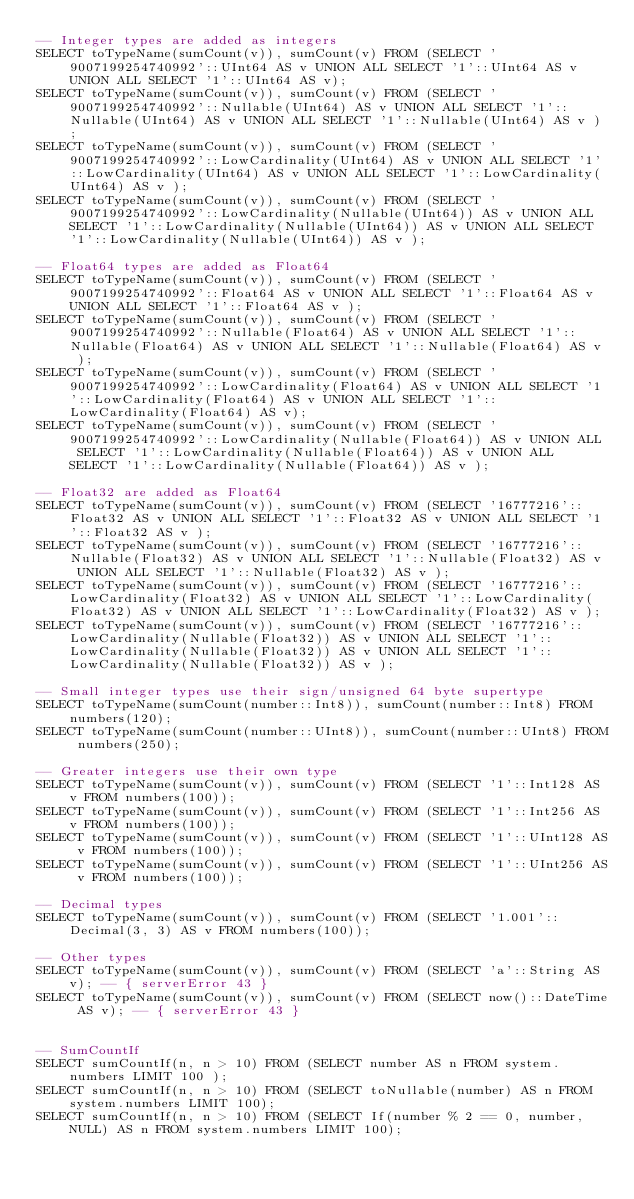Convert code to text. <code><loc_0><loc_0><loc_500><loc_500><_SQL_>-- Integer types are added as integers
SELECT toTypeName(sumCount(v)), sumCount(v) FROM (SELECT '9007199254740992'::UInt64 AS v UNION ALL SELECT '1'::UInt64 AS v UNION ALL SELECT '1'::UInt64 AS v);
SELECT toTypeName(sumCount(v)), sumCount(v) FROM (SELECT '9007199254740992'::Nullable(UInt64) AS v UNION ALL SELECT '1'::Nullable(UInt64) AS v UNION ALL SELECT '1'::Nullable(UInt64) AS v );
SELECT toTypeName(sumCount(v)), sumCount(v) FROM (SELECT '9007199254740992'::LowCardinality(UInt64) AS v UNION ALL SELECT '1'::LowCardinality(UInt64) AS v UNION ALL SELECT '1'::LowCardinality(UInt64) AS v );
SELECT toTypeName(sumCount(v)), sumCount(v) FROM (SELECT '9007199254740992'::LowCardinality(Nullable(UInt64)) AS v UNION ALL SELECT '1'::LowCardinality(Nullable(UInt64)) AS v UNION ALL SELECT '1'::LowCardinality(Nullable(UInt64)) AS v );

-- Float64 types are added as Float64
SELECT toTypeName(sumCount(v)), sumCount(v) FROM (SELECT '9007199254740992'::Float64 AS v UNION ALL SELECT '1'::Float64 AS v UNION ALL SELECT '1'::Float64 AS v );
SELECT toTypeName(sumCount(v)), sumCount(v) FROM (SELECT '9007199254740992'::Nullable(Float64) AS v UNION ALL SELECT '1'::Nullable(Float64) AS v UNION ALL SELECT '1'::Nullable(Float64) AS v );
SELECT toTypeName(sumCount(v)), sumCount(v) FROM (SELECT '9007199254740992'::LowCardinality(Float64) AS v UNION ALL SELECT '1'::LowCardinality(Float64) AS v UNION ALL SELECT '1'::LowCardinality(Float64) AS v);
SELECT toTypeName(sumCount(v)), sumCount(v) FROM (SELECT '9007199254740992'::LowCardinality(Nullable(Float64)) AS v UNION ALL SELECT '1'::LowCardinality(Nullable(Float64)) AS v UNION ALL SELECT '1'::LowCardinality(Nullable(Float64)) AS v );

-- Float32 are added as Float64
SELECT toTypeName(sumCount(v)), sumCount(v) FROM (SELECT '16777216'::Float32 AS v UNION ALL SELECT '1'::Float32 AS v UNION ALL SELECT '1'::Float32 AS v );
SELECT toTypeName(sumCount(v)), sumCount(v) FROM (SELECT '16777216'::Nullable(Float32) AS v UNION ALL SELECT '1'::Nullable(Float32) AS v UNION ALL SELECT '1'::Nullable(Float32) AS v );
SELECT toTypeName(sumCount(v)), sumCount(v) FROM (SELECT '16777216'::LowCardinality(Float32) AS v UNION ALL SELECT '1'::LowCardinality(Float32) AS v UNION ALL SELECT '1'::LowCardinality(Float32) AS v );
SELECT toTypeName(sumCount(v)), sumCount(v) FROM (SELECT '16777216'::LowCardinality(Nullable(Float32)) AS v UNION ALL SELECT '1'::LowCardinality(Nullable(Float32)) AS v UNION ALL SELECT '1'::LowCardinality(Nullable(Float32)) AS v );

-- Small integer types use their sign/unsigned 64 byte supertype
SELECT toTypeName(sumCount(number::Int8)), sumCount(number::Int8) FROM numbers(120);
SELECT toTypeName(sumCount(number::UInt8)), sumCount(number::UInt8) FROM numbers(250);

-- Greater integers use their own type
SELECT toTypeName(sumCount(v)), sumCount(v) FROM (SELECT '1'::Int128 AS v FROM numbers(100));
SELECT toTypeName(sumCount(v)), sumCount(v) FROM (SELECT '1'::Int256 AS v FROM numbers(100));
SELECT toTypeName(sumCount(v)), sumCount(v) FROM (SELECT '1'::UInt128 AS v FROM numbers(100));
SELECT toTypeName(sumCount(v)), sumCount(v) FROM (SELECT '1'::UInt256 AS v FROM numbers(100));

-- Decimal types
SELECT toTypeName(sumCount(v)), sumCount(v) FROM (SELECT '1.001'::Decimal(3, 3) AS v FROM numbers(100));

-- Other types
SELECT toTypeName(sumCount(v)), sumCount(v) FROM (SELECT 'a'::String AS v); -- { serverError 43 }
SELECT toTypeName(sumCount(v)), sumCount(v) FROM (SELECT now()::DateTime AS v); -- { serverError 43 }


-- SumCountIf
SELECT sumCountIf(n, n > 10) FROM (SELECT number AS n FROM system.numbers LIMIT 100 );
SELECT sumCountIf(n, n > 10) FROM (SELECT toNullable(number) AS n FROM system.numbers LIMIT 100);
SELECT sumCountIf(n, n > 10) FROM (SELECT If(number % 2 == 0, number, NULL) AS n FROM system.numbers LIMIT 100);
</code> 